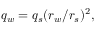Convert formula to latex. <formula><loc_0><loc_0><loc_500><loc_500>q _ { w } = q _ { s } ( r _ { w } / r _ { s } ) ^ { 2 } ,</formula> 